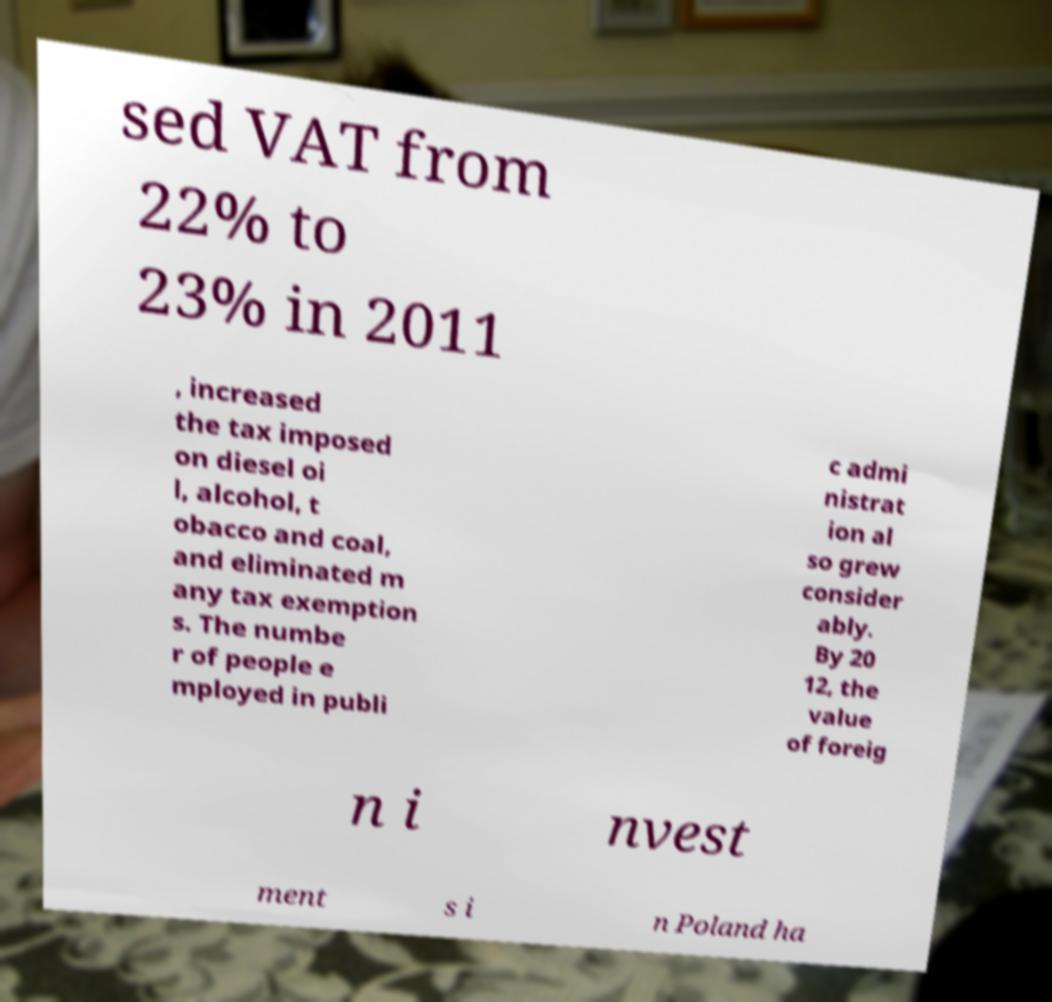Could you extract and type out the text from this image? sed VAT from 22% to 23% in 2011 , increased the tax imposed on diesel oi l, alcohol, t obacco and coal, and eliminated m any tax exemption s. The numbe r of people e mployed in publi c admi nistrat ion al so grew consider ably. By 20 12, the value of foreig n i nvest ment s i n Poland ha 